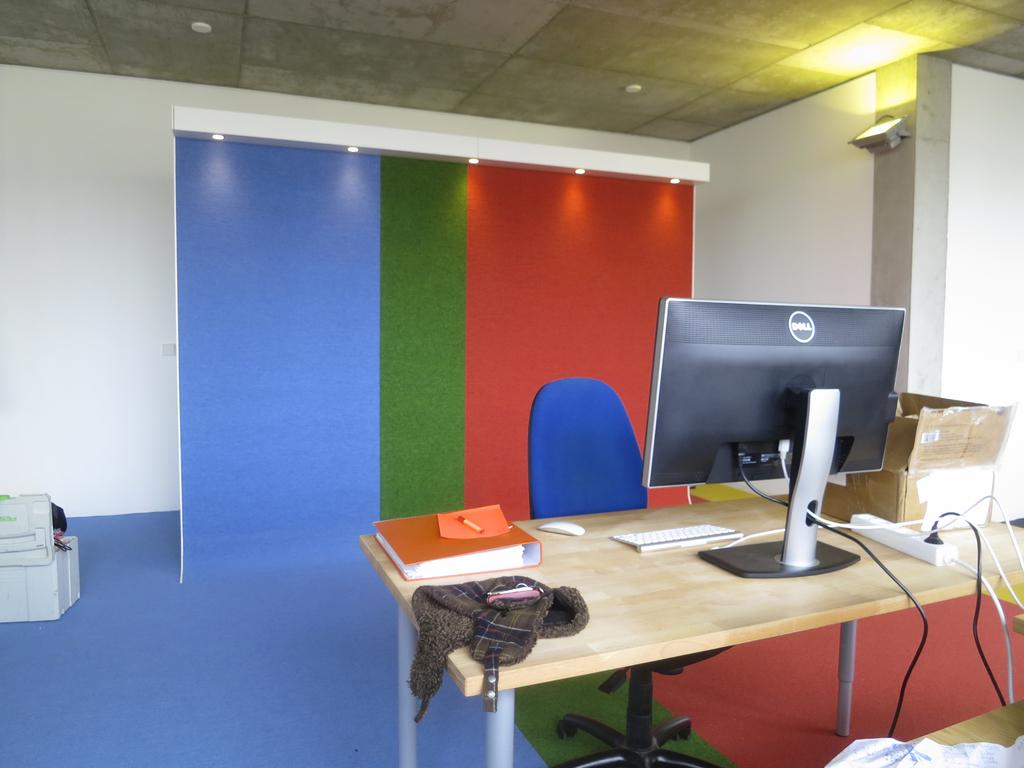<image>
Write a terse but informative summary of the picture. A desk with a Dell monitor sits in front of a colorful backdrop. 